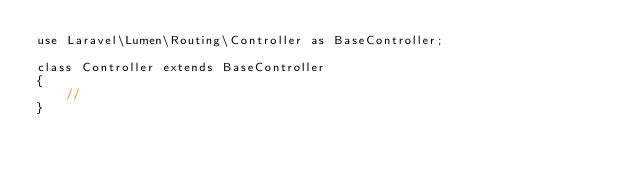<code> <loc_0><loc_0><loc_500><loc_500><_PHP_>use Laravel\Lumen\Routing\Controller as BaseController;

class Controller extends BaseController
{
    //
}
</code> 